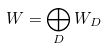<formula> <loc_0><loc_0><loc_500><loc_500>W = \bigoplus _ { D } W _ { D }</formula> 